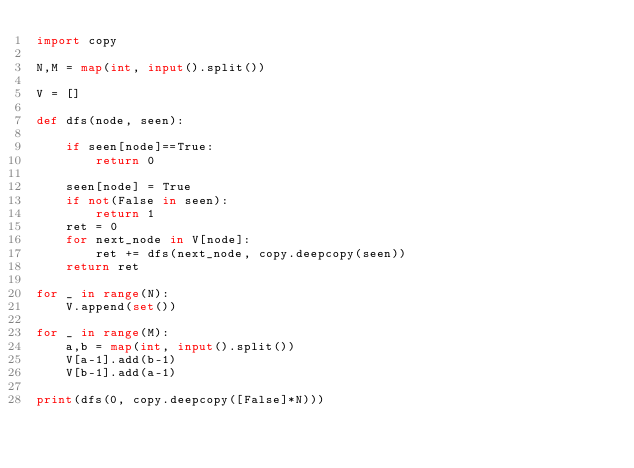Convert code to text. <code><loc_0><loc_0><loc_500><loc_500><_Python_>import copy

N,M = map(int, input().split())

V = []

def dfs(node, seen):

    if seen[node]==True:
        return 0

    seen[node] = True
    if not(False in seen):
        return 1
    ret = 0
    for next_node in V[node]:
        ret += dfs(next_node, copy.deepcopy(seen))
    return ret

for _ in range(N):
    V.append(set())

for _ in range(M):
    a,b = map(int, input().split())
    V[a-1].add(b-1)
    V[b-1].add(a-1)

print(dfs(0, copy.deepcopy([False]*N)))</code> 